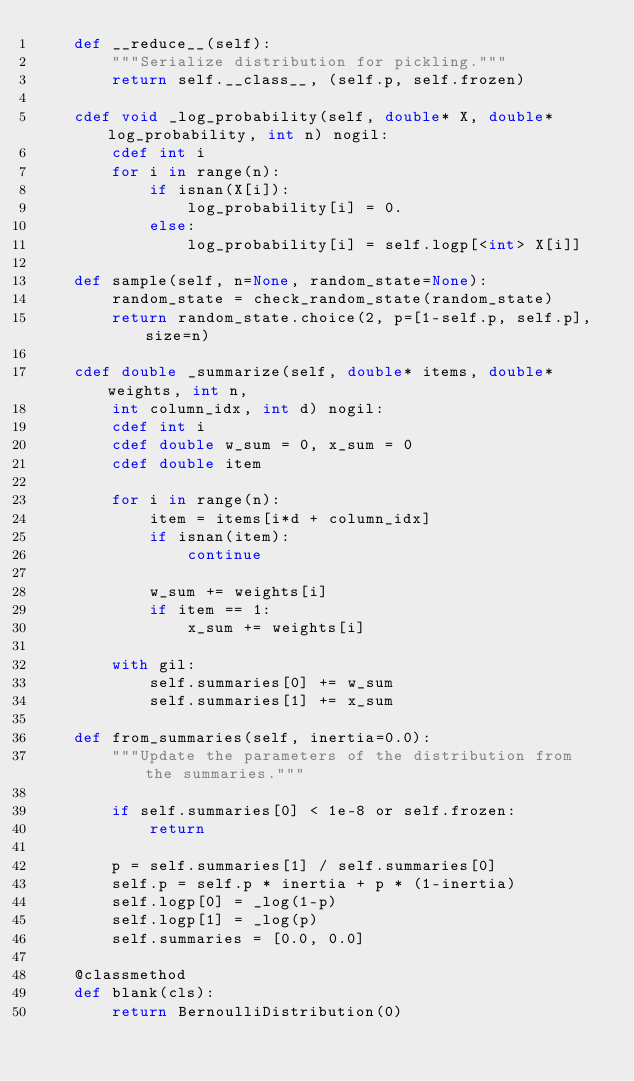<code> <loc_0><loc_0><loc_500><loc_500><_Cython_>	def __reduce__(self):
		"""Serialize distribution for pickling."""
		return self.__class__, (self.p, self.frozen)

	cdef void _log_probability(self, double* X, double* log_probability, int n) nogil:
		cdef int i
		for i in range(n):
			if isnan(X[i]):
				log_probability[i] = 0.
			else:
				log_probability[i] = self.logp[<int> X[i]]

	def sample(self, n=None, random_state=None):
		random_state = check_random_state(random_state)
		return random_state.choice(2, p=[1-self.p, self.p], size=n)

	cdef double _summarize(self, double* items, double* weights, int n,
		int column_idx, int d) nogil:
		cdef int i
		cdef double w_sum = 0, x_sum = 0
		cdef double item

		for i in range(n):
			item = items[i*d + column_idx]
			if isnan(item):
				continue

			w_sum += weights[i]
			if item == 1:
				x_sum += weights[i]

		with gil:
			self.summaries[0] += w_sum
			self.summaries[1] += x_sum

	def from_summaries(self, inertia=0.0):
		"""Update the parameters of the distribution from the summaries."""

		if self.summaries[0] < 1e-8 or self.frozen:
			return

		p = self.summaries[1] / self.summaries[0]
		self.p = self.p * inertia + p * (1-inertia)
		self.logp[0] = _log(1-p)
		self.logp[1] = _log(p)
		self.summaries = [0.0, 0.0]

	@classmethod
	def blank(cls):
		return BernoulliDistribution(0)
</code> 